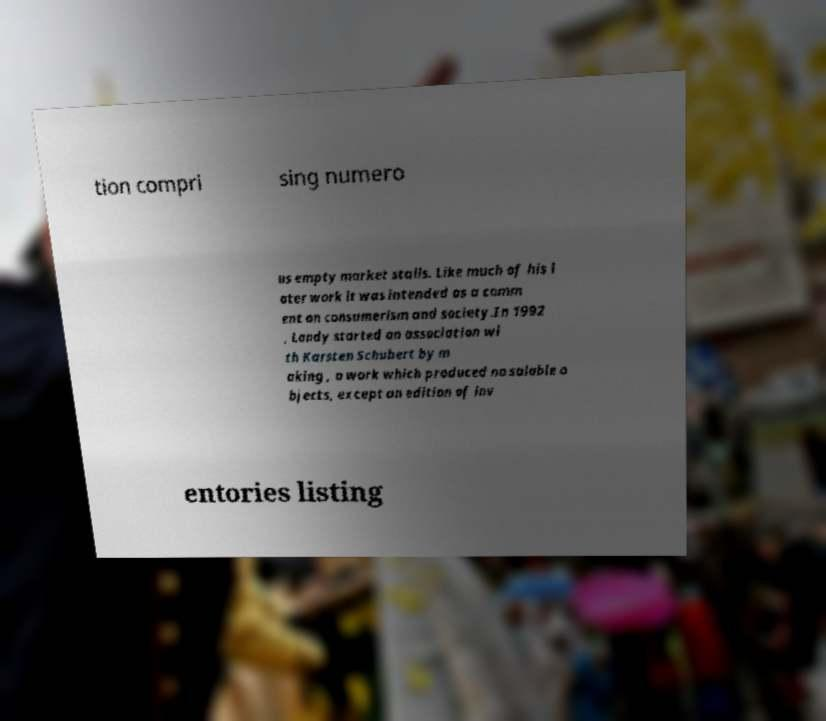There's text embedded in this image that I need extracted. Can you transcribe it verbatim? tion compri sing numero us empty market stalls. Like much of his l ater work it was intended as a comm ent on consumerism and society.In 1992 , Landy started an association wi th Karsten Schubert by m aking , a work which produced no salable o bjects, except an edition of inv entories listing 